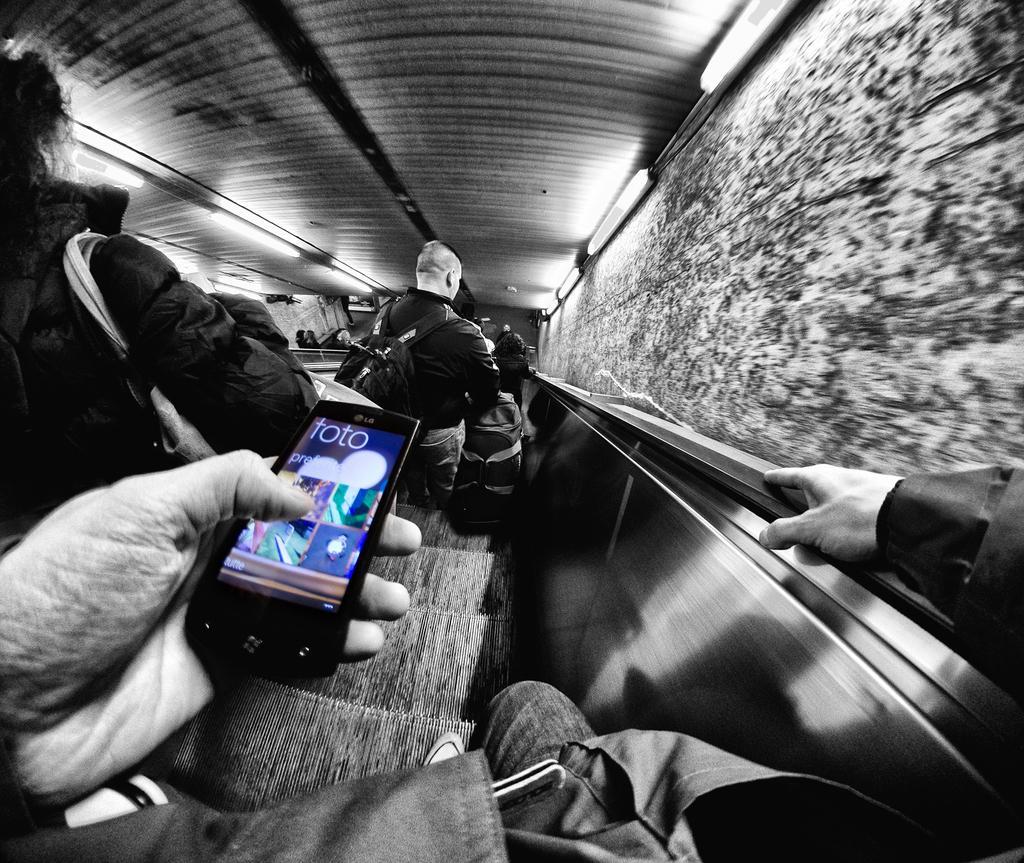How would you summarize this image in a sentence or two? Here we can see person holding mobile in his hand, on the staircase, and here is the wall. 